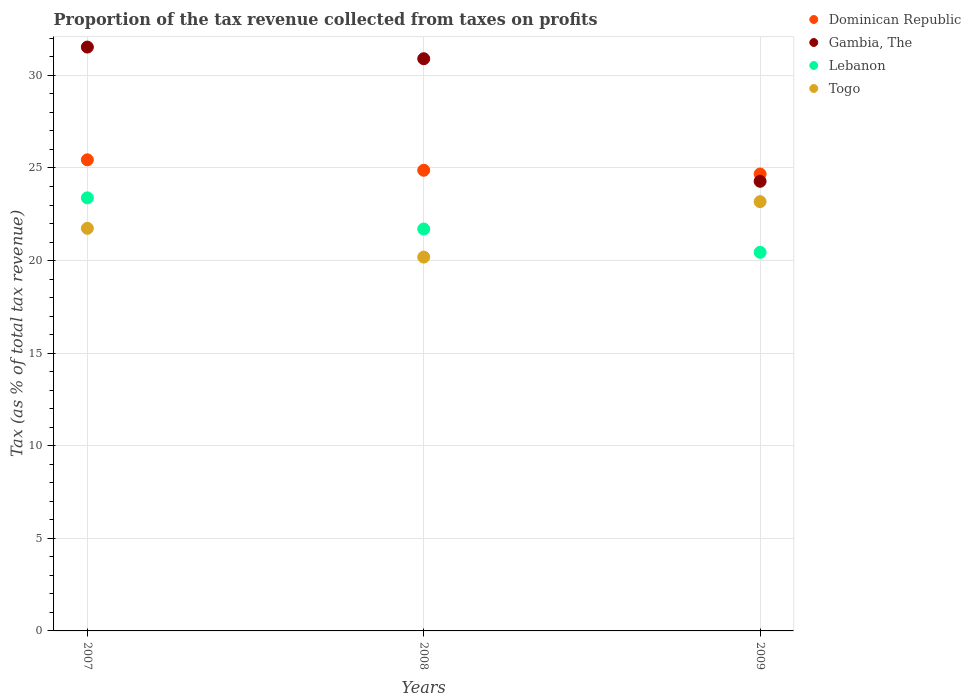Is the number of dotlines equal to the number of legend labels?
Your answer should be very brief. Yes. What is the proportion of the tax revenue collected in Lebanon in 2007?
Give a very brief answer. 23.39. Across all years, what is the maximum proportion of the tax revenue collected in Dominican Republic?
Provide a succinct answer. 25.44. Across all years, what is the minimum proportion of the tax revenue collected in Lebanon?
Your response must be concise. 20.45. In which year was the proportion of the tax revenue collected in Dominican Republic maximum?
Offer a terse response. 2007. In which year was the proportion of the tax revenue collected in Togo minimum?
Make the answer very short. 2008. What is the total proportion of the tax revenue collected in Togo in the graph?
Make the answer very short. 65.11. What is the difference between the proportion of the tax revenue collected in Togo in 2007 and that in 2008?
Keep it short and to the point. 1.55. What is the difference between the proportion of the tax revenue collected in Dominican Republic in 2009 and the proportion of the tax revenue collected in Gambia, The in 2008?
Provide a succinct answer. -6.22. What is the average proportion of the tax revenue collected in Togo per year?
Keep it short and to the point. 21.7. In the year 2007, what is the difference between the proportion of the tax revenue collected in Lebanon and proportion of the tax revenue collected in Dominican Republic?
Your response must be concise. -2.05. In how many years, is the proportion of the tax revenue collected in Togo greater than 7 %?
Keep it short and to the point. 3. What is the ratio of the proportion of the tax revenue collected in Dominican Republic in 2007 to that in 2009?
Ensure brevity in your answer.  1.03. Is the difference between the proportion of the tax revenue collected in Lebanon in 2007 and 2008 greater than the difference between the proportion of the tax revenue collected in Dominican Republic in 2007 and 2008?
Offer a terse response. Yes. What is the difference between the highest and the second highest proportion of the tax revenue collected in Togo?
Provide a succinct answer. 1.44. What is the difference between the highest and the lowest proportion of the tax revenue collected in Togo?
Provide a short and direct response. 2.99. Is the sum of the proportion of the tax revenue collected in Gambia, The in 2007 and 2009 greater than the maximum proportion of the tax revenue collected in Dominican Republic across all years?
Give a very brief answer. Yes. Is it the case that in every year, the sum of the proportion of the tax revenue collected in Togo and proportion of the tax revenue collected in Gambia, The  is greater than the sum of proportion of the tax revenue collected in Dominican Republic and proportion of the tax revenue collected in Lebanon?
Offer a terse response. No. Does the proportion of the tax revenue collected in Gambia, The monotonically increase over the years?
Offer a terse response. No. How many dotlines are there?
Offer a very short reply. 4. How many years are there in the graph?
Offer a terse response. 3. What is the difference between two consecutive major ticks on the Y-axis?
Keep it short and to the point. 5. Are the values on the major ticks of Y-axis written in scientific E-notation?
Provide a short and direct response. No. Does the graph contain grids?
Provide a short and direct response. Yes. How many legend labels are there?
Your answer should be compact. 4. What is the title of the graph?
Your response must be concise. Proportion of the tax revenue collected from taxes on profits. Does "Cameroon" appear as one of the legend labels in the graph?
Offer a very short reply. No. What is the label or title of the Y-axis?
Your answer should be compact. Tax (as % of total tax revenue). What is the Tax (as % of total tax revenue) of Dominican Republic in 2007?
Offer a terse response. 25.44. What is the Tax (as % of total tax revenue) in Gambia, The in 2007?
Give a very brief answer. 31.53. What is the Tax (as % of total tax revenue) of Lebanon in 2007?
Ensure brevity in your answer.  23.39. What is the Tax (as % of total tax revenue) in Togo in 2007?
Give a very brief answer. 21.74. What is the Tax (as % of total tax revenue) of Dominican Republic in 2008?
Your response must be concise. 24.88. What is the Tax (as % of total tax revenue) in Gambia, The in 2008?
Ensure brevity in your answer.  30.9. What is the Tax (as % of total tax revenue) of Lebanon in 2008?
Offer a terse response. 21.7. What is the Tax (as % of total tax revenue) of Togo in 2008?
Keep it short and to the point. 20.19. What is the Tax (as % of total tax revenue) in Dominican Republic in 2009?
Your answer should be very brief. 24.67. What is the Tax (as % of total tax revenue) in Gambia, The in 2009?
Ensure brevity in your answer.  24.28. What is the Tax (as % of total tax revenue) in Lebanon in 2009?
Provide a succinct answer. 20.45. What is the Tax (as % of total tax revenue) in Togo in 2009?
Your response must be concise. 23.18. Across all years, what is the maximum Tax (as % of total tax revenue) in Dominican Republic?
Your response must be concise. 25.44. Across all years, what is the maximum Tax (as % of total tax revenue) of Gambia, The?
Offer a very short reply. 31.53. Across all years, what is the maximum Tax (as % of total tax revenue) of Lebanon?
Your answer should be compact. 23.39. Across all years, what is the maximum Tax (as % of total tax revenue) in Togo?
Your answer should be compact. 23.18. Across all years, what is the minimum Tax (as % of total tax revenue) of Dominican Republic?
Ensure brevity in your answer.  24.67. Across all years, what is the minimum Tax (as % of total tax revenue) of Gambia, The?
Give a very brief answer. 24.28. Across all years, what is the minimum Tax (as % of total tax revenue) in Lebanon?
Offer a very short reply. 20.45. Across all years, what is the minimum Tax (as % of total tax revenue) of Togo?
Your answer should be compact. 20.19. What is the total Tax (as % of total tax revenue) in Dominican Republic in the graph?
Your response must be concise. 74.99. What is the total Tax (as % of total tax revenue) of Gambia, The in the graph?
Offer a very short reply. 86.71. What is the total Tax (as % of total tax revenue) in Lebanon in the graph?
Provide a succinct answer. 65.54. What is the total Tax (as % of total tax revenue) of Togo in the graph?
Provide a succinct answer. 65.11. What is the difference between the Tax (as % of total tax revenue) of Dominican Republic in 2007 and that in 2008?
Make the answer very short. 0.56. What is the difference between the Tax (as % of total tax revenue) of Gambia, The in 2007 and that in 2008?
Provide a succinct answer. 0.63. What is the difference between the Tax (as % of total tax revenue) of Lebanon in 2007 and that in 2008?
Provide a short and direct response. 1.68. What is the difference between the Tax (as % of total tax revenue) in Togo in 2007 and that in 2008?
Keep it short and to the point. 1.55. What is the difference between the Tax (as % of total tax revenue) of Dominican Republic in 2007 and that in 2009?
Ensure brevity in your answer.  0.77. What is the difference between the Tax (as % of total tax revenue) of Gambia, The in 2007 and that in 2009?
Provide a succinct answer. 7.25. What is the difference between the Tax (as % of total tax revenue) of Lebanon in 2007 and that in 2009?
Provide a short and direct response. 2.94. What is the difference between the Tax (as % of total tax revenue) in Togo in 2007 and that in 2009?
Offer a terse response. -1.44. What is the difference between the Tax (as % of total tax revenue) of Dominican Republic in 2008 and that in 2009?
Offer a terse response. 0.2. What is the difference between the Tax (as % of total tax revenue) in Gambia, The in 2008 and that in 2009?
Make the answer very short. 6.62. What is the difference between the Tax (as % of total tax revenue) in Lebanon in 2008 and that in 2009?
Provide a succinct answer. 1.26. What is the difference between the Tax (as % of total tax revenue) of Togo in 2008 and that in 2009?
Provide a succinct answer. -2.99. What is the difference between the Tax (as % of total tax revenue) of Dominican Republic in 2007 and the Tax (as % of total tax revenue) of Gambia, The in 2008?
Provide a succinct answer. -5.46. What is the difference between the Tax (as % of total tax revenue) in Dominican Republic in 2007 and the Tax (as % of total tax revenue) in Lebanon in 2008?
Give a very brief answer. 3.74. What is the difference between the Tax (as % of total tax revenue) of Dominican Republic in 2007 and the Tax (as % of total tax revenue) of Togo in 2008?
Provide a short and direct response. 5.25. What is the difference between the Tax (as % of total tax revenue) of Gambia, The in 2007 and the Tax (as % of total tax revenue) of Lebanon in 2008?
Give a very brief answer. 9.82. What is the difference between the Tax (as % of total tax revenue) in Gambia, The in 2007 and the Tax (as % of total tax revenue) in Togo in 2008?
Your response must be concise. 11.34. What is the difference between the Tax (as % of total tax revenue) in Lebanon in 2007 and the Tax (as % of total tax revenue) in Togo in 2008?
Make the answer very short. 3.2. What is the difference between the Tax (as % of total tax revenue) of Dominican Republic in 2007 and the Tax (as % of total tax revenue) of Gambia, The in 2009?
Your answer should be very brief. 1.16. What is the difference between the Tax (as % of total tax revenue) in Dominican Republic in 2007 and the Tax (as % of total tax revenue) in Lebanon in 2009?
Your answer should be very brief. 4.99. What is the difference between the Tax (as % of total tax revenue) of Dominican Republic in 2007 and the Tax (as % of total tax revenue) of Togo in 2009?
Provide a succinct answer. 2.26. What is the difference between the Tax (as % of total tax revenue) of Gambia, The in 2007 and the Tax (as % of total tax revenue) of Lebanon in 2009?
Make the answer very short. 11.08. What is the difference between the Tax (as % of total tax revenue) of Gambia, The in 2007 and the Tax (as % of total tax revenue) of Togo in 2009?
Ensure brevity in your answer.  8.35. What is the difference between the Tax (as % of total tax revenue) of Lebanon in 2007 and the Tax (as % of total tax revenue) of Togo in 2009?
Ensure brevity in your answer.  0.2. What is the difference between the Tax (as % of total tax revenue) of Dominican Republic in 2008 and the Tax (as % of total tax revenue) of Gambia, The in 2009?
Make the answer very short. 0.6. What is the difference between the Tax (as % of total tax revenue) in Dominican Republic in 2008 and the Tax (as % of total tax revenue) in Lebanon in 2009?
Provide a short and direct response. 4.43. What is the difference between the Tax (as % of total tax revenue) of Dominican Republic in 2008 and the Tax (as % of total tax revenue) of Togo in 2009?
Your answer should be very brief. 1.69. What is the difference between the Tax (as % of total tax revenue) in Gambia, The in 2008 and the Tax (as % of total tax revenue) in Lebanon in 2009?
Your answer should be compact. 10.45. What is the difference between the Tax (as % of total tax revenue) of Gambia, The in 2008 and the Tax (as % of total tax revenue) of Togo in 2009?
Keep it short and to the point. 7.72. What is the difference between the Tax (as % of total tax revenue) in Lebanon in 2008 and the Tax (as % of total tax revenue) in Togo in 2009?
Offer a very short reply. -1.48. What is the average Tax (as % of total tax revenue) in Dominican Republic per year?
Offer a terse response. 25. What is the average Tax (as % of total tax revenue) in Gambia, The per year?
Give a very brief answer. 28.9. What is the average Tax (as % of total tax revenue) of Lebanon per year?
Offer a very short reply. 21.85. What is the average Tax (as % of total tax revenue) of Togo per year?
Offer a terse response. 21.7. In the year 2007, what is the difference between the Tax (as % of total tax revenue) in Dominican Republic and Tax (as % of total tax revenue) in Gambia, The?
Your answer should be compact. -6.09. In the year 2007, what is the difference between the Tax (as % of total tax revenue) in Dominican Republic and Tax (as % of total tax revenue) in Lebanon?
Provide a succinct answer. 2.05. In the year 2007, what is the difference between the Tax (as % of total tax revenue) in Dominican Republic and Tax (as % of total tax revenue) in Togo?
Provide a succinct answer. 3.7. In the year 2007, what is the difference between the Tax (as % of total tax revenue) of Gambia, The and Tax (as % of total tax revenue) of Lebanon?
Offer a very short reply. 8.14. In the year 2007, what is the difference between the Tax (as % of total tax revenue) in Gambia, The and Tax (as % of total tax revenue) in Togo?
Ensure brevity in your answer.  9.79. In the year 2007, what is the difference between the Tax (as % of total tax revenue) of Lebanon and Tax (as % of total tax revenue) of Togo?
Make the answer very short. 1.65. In the year 2008, what is the difference between the Tax (as % of total tax revenue) in Dominican Republic and Tax (as % of total tax revenue) in Gambia, The?
Offer a very short reply. -6.02. In the year 2008, what is the difference between the Tax (as % of total tax revenue) of Dominican Republic and Tax (as % of total tax revenue) of Lebanon?
Ensure brevity in your answer.  3.17. In the year 2008, what is the difference between the Tax (as % of total tax revenue) of Dominican Republic and Tax (as % of total tax revenue) of Togo?
Your response must be concise. 4.69. In the year 2008, what is the difference between the Tax (as % of total tax revenue) in Gambia, The and Tax (as % of total tax revenue) in Lebanon?
Ensure brevity in your answer.  9.2. In the year 2008, what is the difference between the Tax (as % of total tax revenue) of Gambia, The and Tax (as % of total tax revenue) of Togo?
Give a very brief answer. 10.71. In the year 2008, what is the difference between the Tax (as % of total tax revenue) in Lebanon and Tax (as % of total tax revenue) in Togo?
Your answer should be very brief. 1.52. In the year 2009, what is the difference between the Tax (as % of total tax revenue) of Dominican Republic and Tax (as % of total tax revenue) of Gambia, The?
Provide a succinct answer. 0.39. In the year 2009, what is the difference between the Tax (as % of total tax revenue) in Dominican Republic and Tax (as % of total tax revenue) in Lebanon?
Your answer should be very brief. 4.23. In the year 2009, what is the difference between the Tax (as % of total tax revenue) in Dominican Republic and Tax (as % of total tax revenue) in Togo?
Your answer should be compact. 1.49. In the year 2009, what is the difference between the Tax (as % of total tax revenue) of Gambia, The and Tax (as % of total tax revenue) of Lebanon?
Ensure brevity in your answer.  3.83. In the year 2009, what is the difference between the Tax (as % of total tax revenue) in Gambia, The and Tax (as % of total tax revenue) in Togo?
Ensure brevity in your answer.  1.1. In the year 2009, what is the difference between the Tax (as % of total tax revenue) of Lebanon and Tax (as % of total tax revenue) of Togo?
Your answer should be compact. -2.74. What is the ratio of the Tax (as % of total tax revenue) in Dominican Republic in 2007 to that in 2008?
Offer a very short reply. 1.02. What is the ratio of the Tax (as % of total tax revenue) of Gambia, The in 2007 to that in 2008?
Give a very brief answer. 1.02. What is the ratio of the Tax (as % of total tax revenue) of Lebanon in 2007 to that in 2008?
Your answer should be compact. 1.08. What is the ratio of the Tax (as % of total tax revenue) of Dominican Republic in 2007 to that in 2009?
Ensure brevity in your answer.  1.03. What is the ratio of the Tax (as % of total tax revenue) in Gambia, The in 2007 to that in 2009?
Ensure brevity in your answer.  1.3. What is the ratio of the Tax (as % of total tax revenue) of Lebanon in 2007 to that in 2009?
Provide a succinct answer. 1.14. What is the ratio of the Tax (as % of total tax revenue) of Togo in 2007 to that in 2009?
Your answer should be compact. 0.94. What is the ratio of the Tax (as % of total tax revenue) in Dominican Republic in 2008 to that in 2009?
Your answer should be compact. 1.01. What is the ratio of the Tax (as % of total tax revenue) in Gambia, The in 2008 to that in 2009?
Offer a terse response. 1.27. What is the ratio of the Tax (as % of total tax revenue) in Lebanon in 2008 to that in 2009?
Keep it short and to the point. 1.06. What is the ratio of the Tax (as % of total tax revenue) in Togo in 2008 to that in 2009?
Provide a short and direct response. 0.87. What is the difference between the highest and the second highest Tax (as % of total tax revenue) in Dominican Republic?
Give a very brief answer. 0.56. What is the difference between the highest and the second highest Tax (as % of total tax revenue) in Gambia, The?
Ensure brevity in your answer.  0.63. What is the difference between the highest and the second highest Tax (as % of total tax revenue) in Lebanon?
Offer a terse response. 1.68. What is the difference between the highest and the second highest Tax (as % of total tax revenue) of Togo?
Your answer should be very brief. 1.44. What is the difference between the highest and the lowest Tax (as % of total tax revenue) of Dominican Republic?
Provide a short and direct response. 0.77. What is the difference between the highest and the lowest Tax (as % of total tax revenue) in Gambia, The?
Keep it short and to the point. 7.25. What is the difference between the highest and the lowest Tax (as % of total tax revenue) in Lebanon?
Keep it short and to the point. 2.94. What is the difference between the highest and the lowest Tax (as % of total tax revenue) in Togo?
Your answer should be very brief. 2.99. 